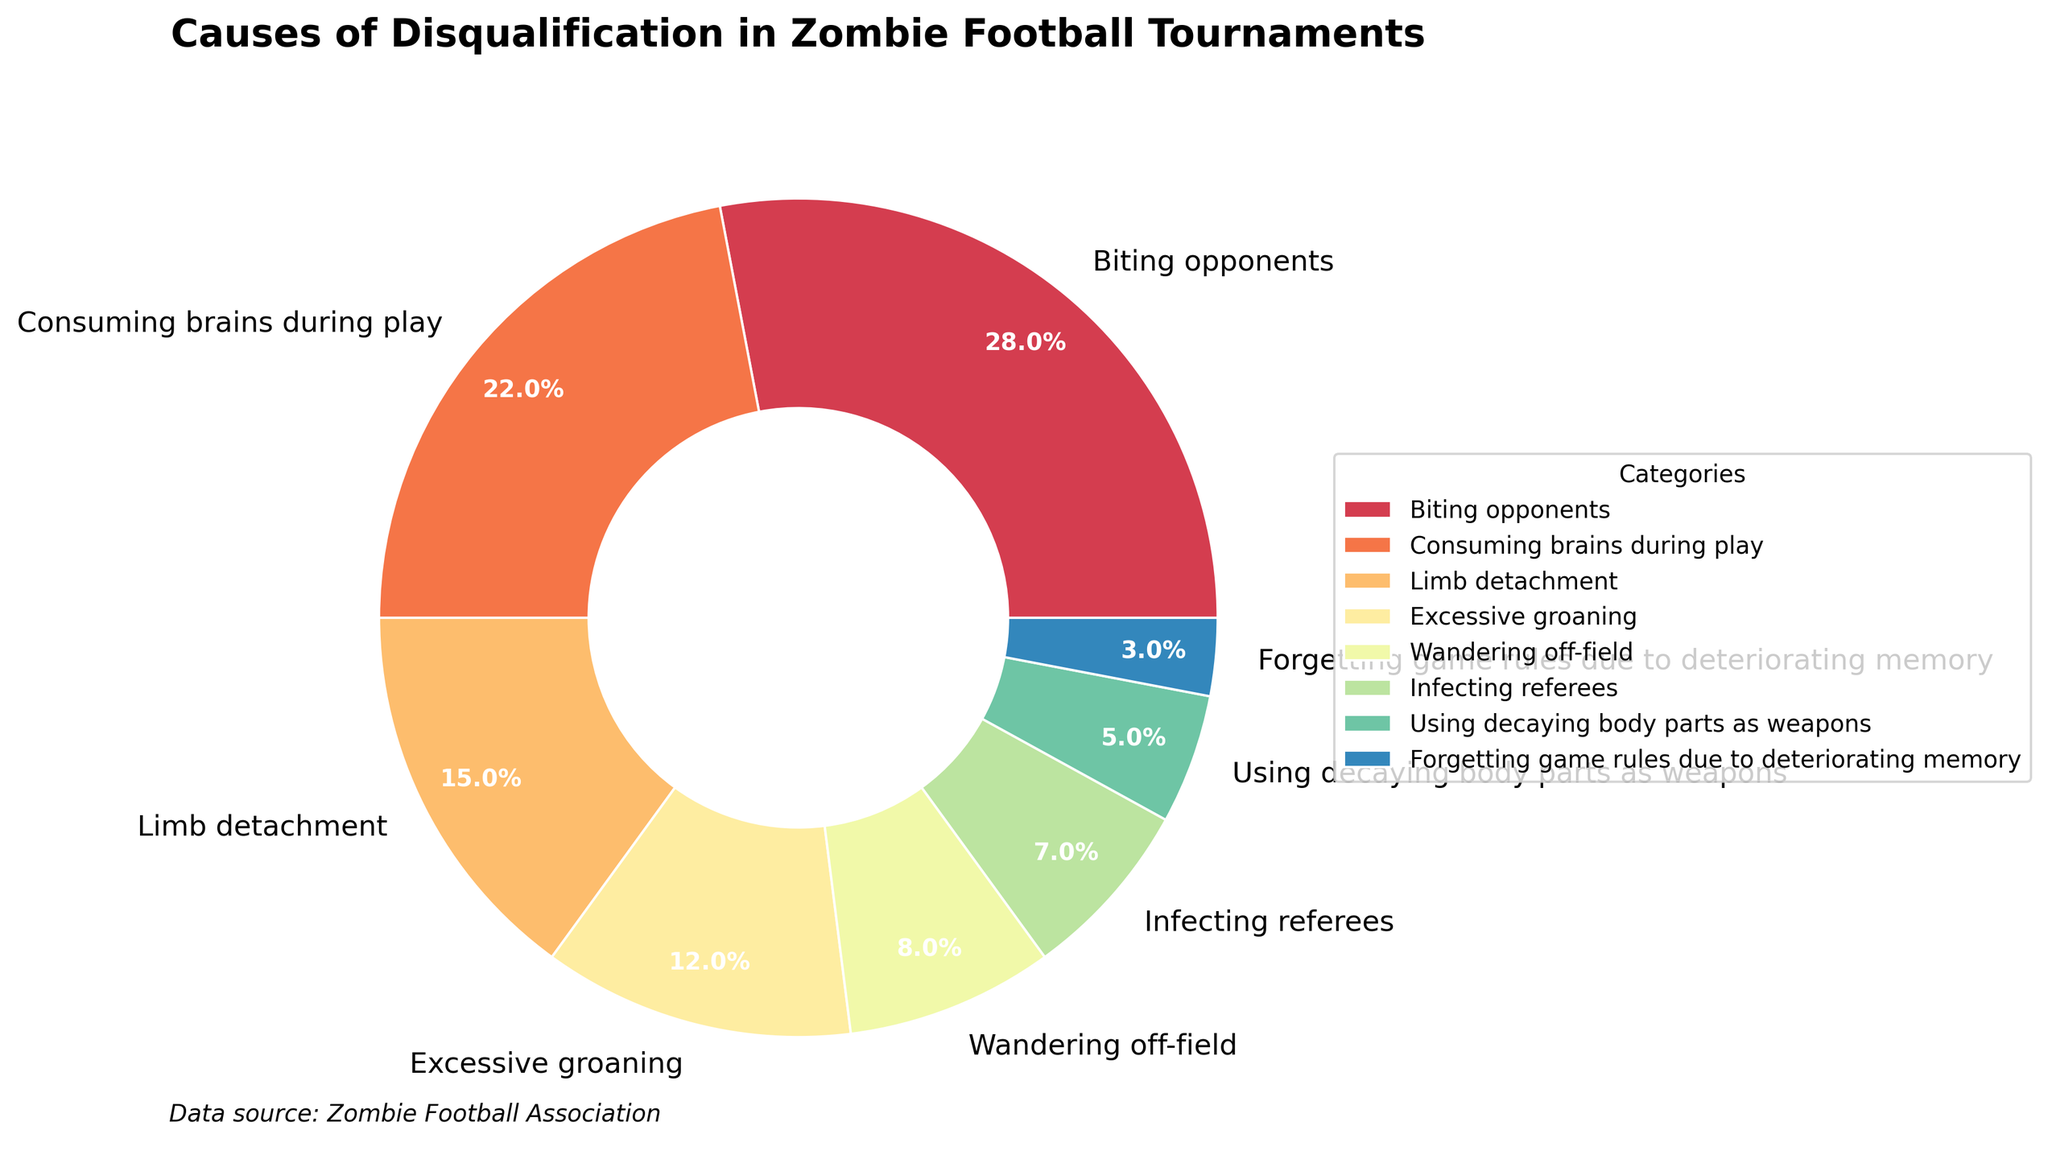Which cause of disqualification contributes the highest percentage? The figure clearly shows the category "Biting opponents" taking up the largest segment of the pie chart. Its percentage is 28%, which is higher than any other cause.
Answer: Biting opponents Which category has the smallest percentage? Observing the pie chart, the smallest segment corresponds to "Forgetting game rules due to deteriorating memory," which has a percentage of 3%.
Answer: Forgetting game rules due to deteriorating memory What percentage of disqualifications is caused by "Excessive groaning" and "Wandering off-field" combined? Summing up the percentages for "Excessive groaning" (12%) and "Wandering off-field" (8%), we get 12% + 8% = 20%.
Answer: 20% Is "Consuming brains during play" more or less common than "Limb detachment"? By comparing the two segments in the pie chart, "Consuming brains during play" (22%) is more common than "Limb detachment" (15%).
Answer: More common How does the percentage of "Infecting referees" compare to "Using decaying body parts as weapons"? The pie chart shows the segment for "Infecting referees" at 7%, while "Using decaying body parts as weapons" is at 5%. Therefore, "Infecting referees" is higher.
Answer: Infecting referees is higher Which cause of disqualification has a percentage closest to the average of all categories? The average percentage is found by summing all the category percentages and dividing by the number of categories: (28 + 22 + 15 + 12 + 8 + 7 + 5 + 3) / 8 = 12.5%. "Excessive groaning" has a percentage of 12%, which is closest to 12.5%.
Answer: Excessive groaning What is the difference in percentage between the highest and the lowest causes of disqualification? The highest cause of disqualification is "Biting opponents" at 28%, and the lowest is "Forgetting game rules due to deteriorating memory" at 3%. The difference is 28% - 3% = 25%.
Answer: 25% What fraction of disqualifications are due to "Biting opponents" and "Consuming brains during play" combined? Adding the percentages of "Biting opponents" (28%) and "Consuming brains during play" (22%) gives 28% + 22% = 50%. Thus, the fraction is 50/100 = 1/2 or 0.5.
Answer: 0.5 What visual aspect helps to distinguish the categories in the pie chart? The categories are distinguished by different colors used for each segment, aiding in visual separation.
Answer: Different colors What total percentage do "Limb detachment," "Wandering off-field," and "Using decaying body parts as weapons" account for? Adding the percentages for "Limb detachment" (15%), "Wandering off-field" (8%), and "Using decaying body parts as weapons" (5%) gives 15% + 8% + 5% = 28%.
Answer: 28% 